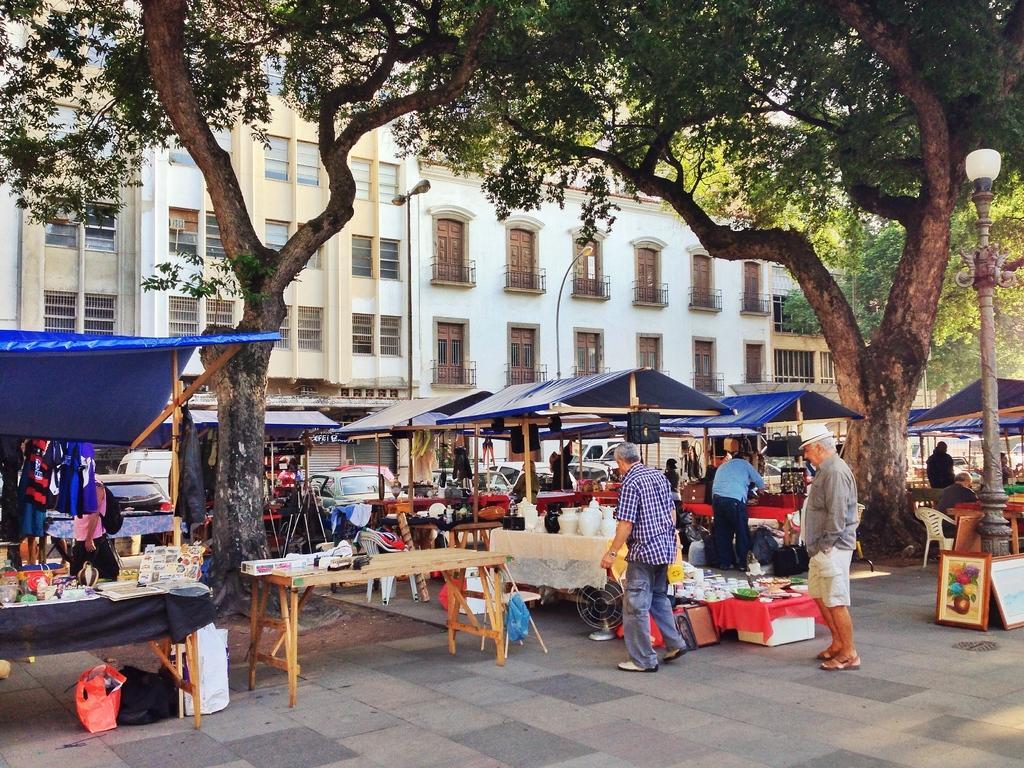In one or two sentences, can you explain what this image depicts? In the picture we can see a people are standing near the tables, in the tents and in the background we can see a trees, buildings, with doors and windows and light poles, and we can see some photo frames near the light pole. 